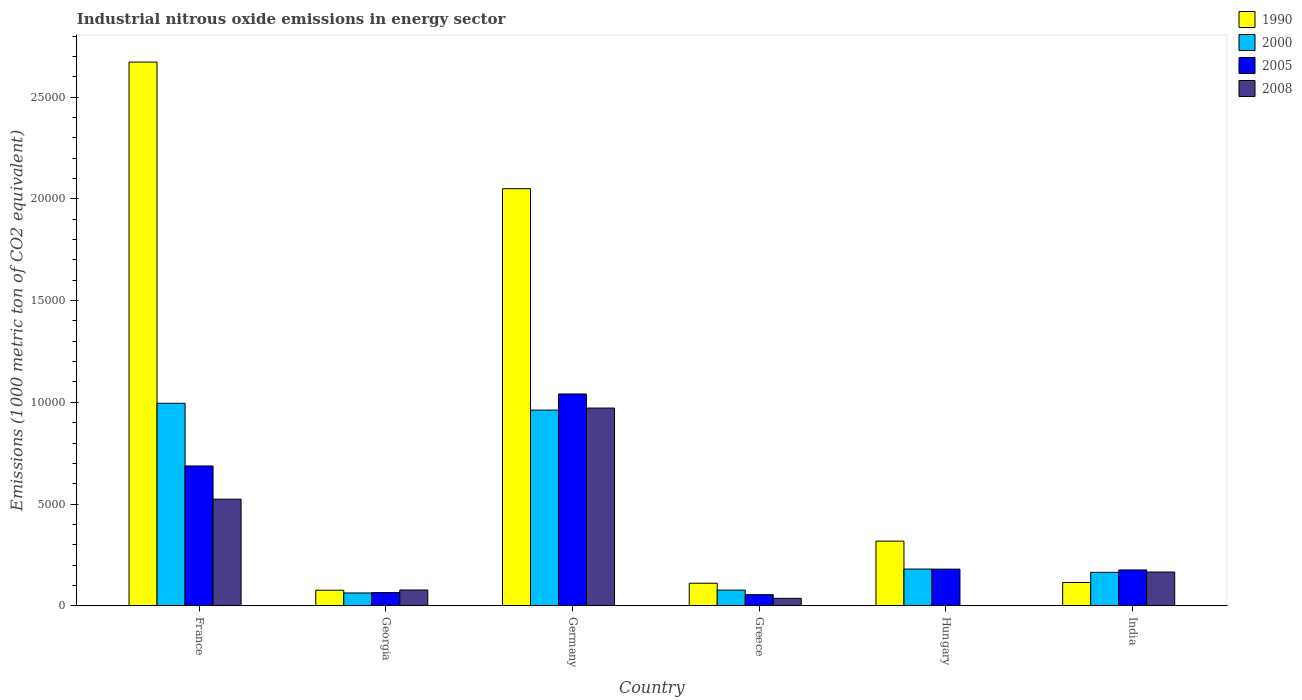How many different coloured bars are there?
Your answer should be compact. 4. How many groups of bars are there?
Provide a short and direct response. 6. Are the number of bars per tick equal to the number of legend labels?
Your answer should be compact. Yes. Are the number of bars on each tick of the X-axis equal?
Provide a succinct answer. Yes. How many bars are there on the 6th tick from the left?
Make the answer very short. 4. In how many cases, is the number of bars for a given country not equal to the number of legend labels?
Give a very brief answer. 0. What is the amount of industrial nitrous oxide emitted in 1990 in Germany?
Your answer should be compact. 2.05e+04. Across all countries, what is the maximum amount of industrial nitrous oxide emitted in 2008?
Your response must be concise. 9718.4. Across all countries, what is the minimum amount of industrial nitrous oxide emitted in 2005?
Offer a terse response. 545.8. In which country was the amount of industrial nitrous oxide emitted in 1990 maximum?
Make the answer very short. France. In which country was the amount of industrial nitrous oxide emitted in 2008 minimum?
Your answer should be compact. Hungary. What is the total amount of industrial nitrous oxide emitted in 2005 in the graph?
Keep it short and to the point. 2.20e+04. What is the difference between the amount of industrial nitrous oxide emitted in 2005 in France and that in Hungary?
Your answer should be compact. 5069.6. What is the difference between the amount of industrial nitrous oxide emitted in 2000 in France and the amount of industrial nitrous oxide emitted in 2005 in Hungary?
Give a very brief answer. 8151.8. What is the average amount of industrial nitrous oxide emitted in 2008 per country?
Your response must be concise. 2961.57. What is the difference between the amount of industrial nitrous oxide emitted of/in 2008 and amount of industrial nitrous oxide emitted of/in 2005 in France?
Offer a terse response. -1630.3. What is the ratio of the amount of industrial nitrous oxide emitted in 2005 in Germany to that in Greece?
Keep it short and to the point. 19.07. Is the amount of industrial nitrous oxide emitted in 2008 in Georgia less than that in India?
Ensure brevity in your answer.  Yes. What is the difference between the highest and the second highest amount of industrial nitrous oxide emitted in 1990?
Offer a very short reply. 6222.7. What is the difference between the highest and the lowest amount of industrial nitrous oxide emitted in 2005?
Your answer should be compact. 9863.1. Is the sum of the amount of industrial nitrous oxide emitted in 2008 in Georgia and Greece greater than the maximum amount of industrial nitrous oxide emitted in 2000 across all countries?
Offer a terse response. No. Is it the case that in every country, the sum of the amount of industrial nitrous oxide emitted in 2008 and amount of industrial nitrous oxide emitted in 1990 is greater than the sum of amount of industrial nitrous oxide emitted in 2000 and amount of industrial nitrous oxide emitted in 2005?
Provide a succinct answer. No. What does the 3rd bar from the right in Greece represents?
Your response must be concise. 2000. Is it the case that in every country, the sum of the amount of industrial nitrous oxide emitted in 1990 and amount of industrial nitrous oxide emitted in 2000 is greater than the amount of industrial nitrous oxide emitted in 2008?
Your answer should be very brief. Yes. How many bars are there?
Ensure brevity in your answer.  24. What is the difference between two consecutive major ticks on the Y-axis?
Keep it short and to the point. 5000. Does the graph contain any zero values?
Your answer should be compact. No. Does the graph contain grids?
Your answer should be very brief. No. Where does the legend appear in the graph?
Ensure brevity in your answer.  Top right. How many legend labels are there?
Make the answer very short. 4. How are the legend labels stacked?
Your answer should be very brief. Vertical. What is the title of the graph?
Provide a succinct answer. Industrial nitrous oxide emissions in energy sector. What is the label or title of the X-axis?
Make the answer very short. Country. What is the label or title of the Y-axis?
Provide a short and direct response. Emissions (1000 metric ton of CO2 equivalent). What is the Emissions (1000 metric ton of CO2 equivalent) in 1990 in France?
Your answer should be compact. 2.67e+04. What is the Emissions (1000 metric ton of CO2 equivalent) in 2000 in France?
Your answer should be compact. 9953.8. What is the Emissions (1000 metric ton of CO2 equivalent) of 2005 in France?
Make the answer very short. 6871.6. What is the Emissions (1000 metric ton of CO2 equivalent) in 2008 in France?
Make the answer very short. 5241.3. What is the Emissions (1000 metric ton of CO2 equivalent) in 1990 in Georgia?
Provide a short and direct response. 765.3. What is the Emissions (1000 metric ton of CO2 equivalent) of 2000 in Georgia?
Your answer should be very brief. 630.5. What is the Emissions (1000 metric ton of CO2 equivalent) in 2005 in Georgia?
Give a very brief answer. 650.1. What is the Emissions (1000 metric ton of CO2 equivalent) in 2008 in Georgia?
Ensure brevity in your answer.  776.5. What is the Emissions (1000 metric ton of CO2 equivalent) of 1990 in Germany?
Make the answer very short. 2.05e+04. What is the Emissions (1000 metric ton of CO2 equivalent) of 2000 in Germany?
Make the answer very short. 9617.9. What is the Emissions (1000 metric ton of CO2 equivalent) of 2005 in Germany?
Provide a short and direct response. 1.04e+04. What is the Emissions (1000 metric ton of CO2 equivalent) in 2008 in Germany?
Offer a very short reply. 9718.4. What is the Emissions (1000 metric ton of CO2 equivalent) in 1990 in Greece?
Give a very brief answer. 1109.1. What is the Emissions (1000 metric ton of CO2 equivalent) in 2000 in Greece?
Your answer should be compact. 771. What is the Emissions (1000 metric ton of CO2 equivalent) of 2005 in Greece?
Offer a terse response. 545.8. What is the Emissions (1000 metric ton of CO2 equivalent) in 2008 in Greece?
Provide a short and direct response. 367.4. What is the Emissions (1000 metric ton of CO2 equivalent) of 1990 in Hungary?
Give a very brief answer. 3178.6. What is the Emissions (1000 metric ton of CO2 equivalent) in 2000 in Hungary?
Ensure brevity in your answer.  1805.4. What is the Emissions (1000 metric ton of CO2 equivalent) in 2005 in Hungary?
Your answer should be very brief. 1802. What is the Emissions (1000 metric ton of CO2 equivalent) in 2008 in Hungary?
Your answer should be compact. 6. What is the Emissions (1000 metric ton of CO2 equivalent) of 1990 in India?
Offer a terse response. 1146.7. What is the Emissions (1000 metric ton of CO2 equivalent) in 2000 in India?
Make the answer very short. 1643.3. What is the Emissions (1000 metric ton of CO2 equivalent) of 2005 in India?
Give a very brief answer. 1761.9. What is the Emissions (1000 metric ton of CO2 equivalent) in 2008 in India?
Provide a short and direct response. 1659.8. Across all countries, what is the maximum Emissions (1000 metric ton of CO2 equivalent) of 1990?
Your response must be concise. 2.67e+04. Across all countries, what is the maximum Emissions (1000 metric ton of CO2 equivalent) of 2000?
Offer a very short reply. 9953.8. Across all countries, what is the maximum Emissions (1000 metric ton of CO2 equivalent) in 2005?
Ensure brevity in your answer.  1.04e+04. Across all countries, what is the maximum Emissions (1000 metric ton of CO2 equivalent) of 2008?
Ensure brevity in your answer.  9718.4. Across all countries, what is the minimum Emissions (1000 metric ton of CO2 equivalent) of 1990?
Provide a short and direct response. 765.3. Across all countries, what is the minimum Emissions (1000 metric ton of CO2 equivalent) of 2000?
Offer a very short reply. 630.5. Across all countries, what is the minimum Emissions (1000 metric ton of CO2 equivalent) of 2005?
Offer a terse response. 545.8. Across all countries, what is the minimum Emissions (1000 metric ton of CO2 equivalent) of 2008?
Offer a terse response. 6. What is the total Emissions (1000 metric ton of CO2 equivalent) of 1990 in the graph?
Offer a very short reply. 5.34e+04. What is the total Emissions (1000 metric ton of CO2 equivalent) in 2000 in the graph?
Ensure brevity in your answer.  2.44e+04. What is the total Emissions (1000 metric ton of CO2 equivalent) of 2005 in the graph?
Keep it short and to the point. 2.20e+04. What is the total Emissions (1000 metric ton of CO2 equivalent) of 2008 in the graph?
Provide a short and direct response. 1.78e+04. What is the difference between the Emissions (1000 metric ton of CO2 equivalent) in 1990 in France and that in Georgia?
Make the answer very short. 2.60e+04. What is the difference between the Emissions (1000 metric ton of CO2 equivalent) of 2000 in France and that in Georgia?
Your answer should be very brief. 9323.3. What is the difference between the Emissions (1000 metric ton of CO2 equivalent) of 2005 in France and that in Georgia?
Your response must be concise. 6221.5. What is the difference between the Emissions (1000 metric ton of CO2 equivalent) in 2008 in France and that in Georgia?
Make the answer very short. 4464.8. What is the difference between the Emissions (1000 metric ton of CO2 equivalent) of 1990 in France and that in Germany?
Your answer should be very brief. 6222.7. What is the difference between the Emissions (1000 metric ton of CO2 equivalent) of 2000 in France and that in Germany?
Provide a short and direct response. 335.9. What is the difference between the Emissions (1000 metric ton of CO2 equivalent) in 2005 in France and that in Germany?
Give a very brief answer. -3537.3. What is the difference between the Emissions (1000 metric ton of CO2 equivalent) of 2008 in France and that in Germany?
Provide a succinct answer. -4477.1. What is the difference between the Emissions (1000 metric ton of CO2 equivalent) in 1990 in France and that in Greece?
Give a very brief answer. 2.56e+04. What is the difference between the Emissions (1000 metric ton of CO2 equivalent) in 2000 in France and that in Greece?
Offer a terse response. 9182.8. What is the difference between the Emissions (1000 metric ton of CO2 equivalent) of 2005 in France and that in Greece?
Ensure brevity in your answer.  6325.8. What is the difference between the Emissions (1000 metric ton of CO2 equivalent) of 2008 in France and that in Greece?
Provide a short and direct response. 4873.9. What is the difference between the Emissions (1000 metric ton of CO2 equivalent) in 1990 in France and that in Hungary?
Your response must be concise. 2.35e+04. What is the difference between the Emissions (1000 metric ton of CO2 equivalent) of 2000 in France and that in Hungary?
Your answer should be compact. 8148.4. What is the difference between the Emissions (1000 metric ton of CO2 equivalent) of 2005 in France and that in Hungary?
Keep it short and to the point. 5069.6. What is the difference between the Emissions (1000 metric ton of CO2 equivalent) of 2008 in France and that in Hungary?
Offer a terse response. 5235.3. What is the difference between the Emissions (1000 metric ton of CO2 equivalent) in 1990 in France and that in India?
Offer a terse response. 2.56e+04. What is the difference between the Emissions (1000 metric ton of CO2 equivalent) of 2000 in France and that in India?
Provide a short and direct response. 8310.5. What is the difference between the Emissions (1000 metric ton of CO2 equivalent) of 2005 in France and that in India?
Your answer should be compact. 5109.7. What is the difference between the Emissions (1000 metric ton of CO2 equivalent) in 2008 in France and that in India?
Your answer should be compact. 3581.5. What is the difference between the Emissions (1000 metric ton of CO2 equivalent) of 1990 in Georgia and that in Germany?
Ensure brevity in your answer.  -1.97e+04. What is the difference between the Emissions (1000 metric ton of CO2 equivalent) in 2000 in Georgia and that in Germany?
Your answer should be very brief. -8987.4. What is the difference between the Emissions (1000 metric ton of CO2 equivalent) in 2005 in Georgia and that in Germany?
Your answer should be very brief. -9758.8. What is the difference between the Emissions (1000 metric ton of CO2 equivalent) in 2008 in Georgia and that in Germany?
Keep it short and to the point. -8941.9. What is the difference between the Emissions (1000 metric ton of CO2 equivalent) in 1990 in Georgia and that in Greece?
Your answer should be very brief. -343.8. What is the difference between the Emissions (1000 metric ton of CO2 equivalent) in 2000 in Georgia and that in Greece?
Give a very brief answer. -140.5. What is the difference between the Emissions (1000 metric ton of CO2 equivalent) of 2005 in Georgia and that in Greece?
Your answer should be compact. 104.3. What is the difference between the Emissions (1000 metric ton of CO2 equivalent) in 2008 in Georgia and that in Greece?
Provide a short and direct response. 409.1. What is the difference between the Emissions (1000 metric ton of CO2 equivalent) in 1990 in Georgia and that in Hungary?
Make the answer very short. -2413.3. What is the difference between the Emissions (1000 metric ton of CO2 equivalent) in 2000 in Georgia and that in Hungary?
Provide a short and direct response. -1174.9. What is the difference between the Emissions (1000 metric ton of CO2 equivalent) in 2005 in Georgia and that in Hungary?
Ensure brevity in your answer.  -1151.9. What is the difference between the Emissions (1000 metric ton of CO2 equivalent) of 2008 in Georgia and that in Hungary?
Give a very brief answer. 770.5. What is the difference between the Emissions (1000 metric ton of CO2 equivalent) of 1990 in Georgia and that in India?
Offer a terse response. -381.4. What is the difference between the Emissions (1000 metric ton of CO2 equivalent) of 2000 in Georgia and that in India?
Offer a very short reply. -1012.8. What is the difference between the Emissions (1000 metric ton of CO2 equivalent) of 2005 in Georgia and that in India?
Your response must be concise. -1111.8. What is the difference between the Emissions (1000 metric ton of CO2 equivalent) of 2008 in Georgia and that in India?
Keep it short and to the point. -883.3. What is the difference between the Emissions (1000 metric ton of CO2 equivalent) of 1990 in Germany and that in Greece?
Ensure brevity in your answer.  1.94e+04. What is the difference between the Emissions (1000 metric ton of CO2 equivalent) of 2000 in Germany and that in Greece?
Make the answer very short. 8846.9. What is the difference between the Emissions (1000 metric ton of CO2 equivalent) in 2005 in Germany and that in Greece?
Your answer should be compact. 9863.1. What is the difference between the Emissions (1000 metric ton of CO2 equivalent) of 2008 in Germany and that in Greece?
Give a very brief answer. 9351. What is the difference between the Emissions (1000 metric ton of CO2 equivalent) in 1990 in Germany and that in Hungary?
Your answer should be compact. 1.73e+04. What is the difference between the Emissions (1000 metric ton of CO2 equivalent) of 2000 in Germany and that in Hungary?
Your answer should be compact. 7812.5. What is the difference between the Emissions (1000 metric ton of CO2 equivalent) of 2005 in Germany and that in Hungary?
Your response must be concise. 8606.9. What is the difference between the Emissions (1000 metric ton of CO2 equivalent) of 2008 in Germany and that in Hungary?
Your response must be concise. 9712.4. What is the difference between the Emissions (1000 metric ton of CO2 equivalent) in 1990 in Germany and that in India?
Give a very brief answer. 1.94e+04. What is the difference between the Emissions (1000 metric ton of CO2 equivalent) in 2000 in Germany and that in India?
Make the answer very short. 7974.6. What is the difference between the Emissions (1000 metric ton of CO2 equivalent) of 2005 in Germany and that in India?
Provide a succinct answer. 8647. What is the difference between the Emissions (1000 metric ton of CO2 equivalent) in 2008 in Germany and that in India?
Your answer should be very brief. 8058.6. What is the difference between the Emissions (1000 metric ton of CO2 equivalent) in 1990 in Greece and that in Hungary?
Your answer should be compact. -2069.5. What is the difference between the Emissions (1000 metric ton of CO2 equivalent) of 2000 in Greece and that in Hungary?
Ensure brevity in your answer.  -1034.4. What is the difference between the Emissions (1000 metric ton of CO2 equivalent) in 2005 in Greece and that in Hungary?
Your answer should be compact. -1256.2. What is the difference between the Emissions (1000 metric ton of CO2 equivalent) in 2008 in Greece and that in Hungary?
Keep it short and to the point. 361.4. What is the difference between the Emissions (1000 metric ton of CO2 equivalent) in 1990 in Greece and that in India?
Your answer should be compact. -37.6. What is the difference between the Emissions (1000 metric ton of CO2 equivalent) in 2000 in Greece and that in India?
Ensure brevity in your answer.  -872.3. What is the difference between the Emissions (1000 metric ton of CO2 equivalent) of 2005 in Greece and that in India?
Provide a succinct answer. -1216.1. What is the difference between the Emissions (1000 metric ton of CO2 equivalent) of 2008 in Greece and that in India?
Keep it short and to the point. -1292.4. What is the difference between the Emissions (1000 metric ton of CO2 equivalent) of 1990 in Hungary and that in India?
Provide a short and direct response. 2031.9. What is the difference between the Emissions (1000 metric ton of CO2 equivalent) in 2000 in Hungary and that in India?
Offer a terse response. 162.1. What is the difference between the Emissions (1000 metric ton of CO2 equivalent) of 2005 in Hungary and that in India?
Give a very brief answer. 40.1. What is the difference between the Emissions (1000 metric ton of CO2 equivalent) in 2008 in Hungary and that in India?
Provide a short and direct response. -1653.8. What is the difference between the Emissions (1000 metric ton of CO2 equivalent) of 1990 in France and the Emissions (1000 metric ton of CO2 equivalent) of 2000 in Georgia?
Give a very brief answer. 2.61e+04. What is the difference between the Emissions (1000 metric ton of CO2 equivalent) in 1990 in France and the Emissions (1000 metric ton of CO2 equivalent) in 2005 in Georgia?
Offer a very short reply. 2.61e+04. What is the difference between the Emissions (1000 metric ton of CO2 equivalent) of 1990 in France and the Emissions (1000 metric ton of CO2 equivalent) of 2008 in Georgia?
Keep it short and to the point. 2.59e+04. What is the difference between the Emissions (1000 metric ton of CO2 equivalent) in 2000 in France and the Emissions (1000 metric ton of CO2 equivalent) in 2005 in Georgia?
Your answer should be very brief. 9303.7. What is the difference between the Emissions (1000 metric ton of CO2 equivalent) of 2000 in France and the Emissions (1000 metric ton of CO2 equivalent) of 2008 in Georgia?
Provide a succinct answer. 9177.3. What is the difference between the Emissions (1000 metric ton of CO2 equivalent) of 2005 in France and the Emissions (1000 metric ton of CO2 equivalent) of 2008 in Georgia?
Keep it short and to the point. 6095.1. What is the difference between the Emissions (1000 metric ton of CO2 equivalent) in 1990 in France and the Emissions (1000 metric ton of CO2 equivalent) in 2000 in Germany?
Provide a short and direct response. 1.71e+04. What is the difference between the Emissions (1000 metric ton of CO2 equivalent) of 1990 in France and the Emissions (1000 metric ton of CO2 equivalent) of 2005 in Germany?
Offer a very short reply. 1.63e+04. What is the difference between the Emissions (1000 metric ton of CO2 equivalent) of 1990 in France and the Emissions (1000 metric ton of CO2 equivalent) of 2008 in Germany?
Your answer should be very brief. 1.70e+04. What is the difference between the Emissions (1000 metric ton of CO2 equivalent) in 2000 in France and the Emissions (1000 metric ton of CO2 equivalent) in 2005 in Germany?
Make the answer very short. -455.1. What is the difference between the Emissions (1000 metric ton of CO2 equivalent) of 2000 in France and the Emissions (1000 metric ton of CO2 equivalent) of 2008 in Germany?
Offer a very short reply. 235.4. What is the difference between the Emissions (1000 metric ton of CO2 equivalent) of 2005 in France and the Emissions (1000 metric ton of CO2 equivalent) of 2008 in Germany?
Ensure brevity in your answer.  -2846.8. What is the difference between the Emissions (1000 metric ton of CO2 equivalent) in 1990 in France and the Emissions (1000 metric ton of CO2 equivalent) in 2000 in Greece?
Ensure brevity in your answer.  2.60e+04. What is the difference between the Emissions (1000 metric ton of CO2 equivalent) in 1990 in France and the Emissions (1000 metric ton of CO2 equivalent) in 2005 in Greece?
Ensure brevity in your answer.  2.62e+04. What is the difference between the Emissions (1000 metric ton of CO2 equivalent) in 1990 in France and the Emissions (1000 metric ton of CO2 equivalent) in 2008 in Greece?
Keep it short and to the point. 2.64e+04. What is the difference between the Emissions (1000 metric ton of CO2 equivalent) in 2000 in France and the Emissions (1000 metric ton of CO2 equivalent) in 2005 in Greece?
Your answer should be very brief. 9408. What is the difference between the Emissions (1000 metric ton of CO2 equivalent) of 2000 in France and the Emissions (1000 metric ton of CO2 equivalent) of 2008 in Greece?
Offer a terse response. 9586.4. What is the difference between the Emissions (1000 metric ton of CO2 equivalent) in 2005 in France and the Emissions (1000 metric ton of CO2 equivalent) in 2008 in Greece?
Make the answer very short. 6504.2. What is the difference between the Emissions (1000 metric ton of CO2 equivalent) in 1990 in France and the Emissions (1000 metric ton of CO2 equivalent) in 2000 in Hungary?
Ensure brevity in your answer.  2.49e+04. What is the difference between the Emissions (1000 metric ton of CO2 equivalent) in 1990 in France and the Emissions (1000 metric ton of CO2 equivalent) in 2005 in Hungary?
Ensure brevity in your answer.  2.49e+04. What is the difference between the Emissions (1000 metric ton of CO2 equivalent) of 1990 in France and the Emissions (1000 metric ton of CO2 equivalent) of 2008 in Hungary?
Keep it short and to the point. 2.67e+04. What is the difference between the Emissions (1000 metric ton of CO2 equivalent) in 2000 in France and the Emissions (1000 metric ton of CO2 equivalent) in 2005 in Hungary?
Provide a succinct answer. 8151.8. What is the difference between the Emissions (1000 metric ton of CO2 equivalent) of 2000 in France and the Emissions (1000 metric ton of CO2 equivalent) of 2008 in Hungary?
Provide a short and direct response. 9947.8. What is the difference between the Emissions (1000 metric ton of CO2 equivalent) of 2005 in France and the Emissions (1000 metric ton of CO2 equivalent) of 2008 in Hungary?
Make the answer very short. 6865.6. What is the difference between the Emissions (1000 metric ton of CO2 equivalent) of 1990 in France and the Emissions (1000 metric ton of CO2 equivalent) of 2000 in India?
Your response must be concise. 2.51e+04. What is the difference between the Emissions (1000 metric ton of CO2 equivalent) in 1990 in France and the Emissions (1000 metric ton of CO2 equivalent) in 2005 in India?
Provide a succinct answer. 2.50e+04. What is the difference between the Emissions (1000 metric ton of CO2 equivalent) of 1990 in France and the Emissions (1000 metric ton of CO2 equivalent) of 2008 in India?
Make the answer very short. 2.51e+04. What is the difference between the Emissions (1000 metric ton of CO2 equivalent) in 2000 in France and the Emissions (1000 metric ton of CO2 equivalent) in 2005 in India?
Ensure brevity in your answer.  8191.9. What is the difference between the Emissions (1000 metric ton of CO2 equivalent) of 2000 in France and the Emissions (1000 metric ton of CO2 equivalent) of 2008 in India?
Provide a succinct answer. 8294. What is the difference between the Emissions (1000 metric ton of CO2 equivalent) of 2005 in France and the Emissions (1000 metric ton of CO2 equivalent) of 2008 in India?
Keep it short and to the point. 5211.8. What is the difference between the Emissions (1000 metric ton of CO2 equivalent) of 1990 in Georgia and the Emissions (1000 metric ton of CO2 equivalent) of 2000 in Germany?
Keep it short and to the point. -8852.6. What is the difference between the Emissions (1000 metric ton of CO2 equivalent) of 1990 in Georgia and the Emissions (1000 metric ton of CO2 equivalent) of 2005 in Germany?
Ensure brevity in your answer.  -9643.6. What is the difference between the Emissions (1000 metric ton of CO2 equivalent) of 1990 in Georgia and the Emissions (1000 metric ton of CO2 equivalent) of 2008 in Germany?
Your answer should be compact. -8953.1. What is the difference between the Emissions (1000 metric ton of CO2 equivalent) in 2000 in Georgia and the Emissions (1000 metric ton of CO2 equivalent) in 2005 in Germany?
Give a very brief answer. -9778.4. What is the difference between the Emissions (1000 metric ton of CO2 equivalent) in 2000 in Georgia and the Emissions (1000 metric ton of CO2 equivalent) in 2008 in Germany?
Keep it short and to the point. -9087.9. What is the difference between the Emissions (1000 metric ton of CO2 equivalent) of 2005 in Georgia and the Emissions (1000 metric ton of CO2 equivalent) of 2008 in Germany?
Offer a terse response. -9068.3. What is the difference between the Emissions (1000 metric ton of CO2 equivalent) of 1990 in Georgia and the Emissions (1000 metric ton of CO2 equivalent) of 2000 in Greece?
Your answer should be compact. -5.7. What is the difference between the Emissions (1000 metric ton of CO2 equivalent) of 1990 in Georgia and the Emissions (1000 metric ton of CO2 equivalent) of 2005 in Greece?
Keep it short and to the point. 219.5. What is the difference between the Emissions (1000 metric ton of CO2 equivalent) of 1990 in Georgia and the Emissions (1000 metric ton of CO2 equivalent) of 2008 in Greece?
Provide a short and direct response. 397.9. What is the difference between the Emissions (1000 metric ton of CO2 equivalent) in 2000 in Georgia and the Emissions (1000 metric ton of CO2 equivalent) in 2005 in Greece?
Keep it short and to the point. 84.7. What is the difference between the Emissions (1000 metric ton of CO2 equivalent) in 2000 in Georgia and the Emissions (1000 metric ton of CO2 equivalent) in 2008 in Greece?
Give a very brief answer. 263.1. What is the difference between the Emissions (1000 metric ton of CO2 equivalent) of 2005 in Georgia and the Emissions (1000 metric ton of CO2 equivalent) of 2008 in Greece?
Keep it short and to the point. 282.7. What is the difference between the Emissions (1000 metric ton of CO2 equivalent) of 1990 in Georgia and the Emissions (1000 metric ton of CO2 equivalent) of 2000 in Hungary?
Give a very brief answer. -1040.1. What is the difference between the Emissions (1000 metric ton of CO2 equivalent) of 1990 in Georgia and the Emissions (1000 metric ton of CO2 equivalent) of 2005 in Hungary?
Give a very brief answer. -1036.7. What is the difference between the Emissions (1000 metric ton of CO2 equivalent) in 1990 in Georgia and the Emissions (1000 metric ton of CO2 equivalent) in 2008 in Hungary?
Provide a short and direct response. 759.3. What is the difference between the Emissions (1000 metric ton of CO2 equivalent) of 2000 in Georgia and the Emissions (1000 metric ton of CO2 equivalent) of 2005 in Hungary?
Keep it short and to the point. -1171.5. What is the difference between the Emissions (1000 metric ton of CO2 equivalent) in 2000 in Georgia and the Emissions (1000 metric ton of CO2 equivalent) in 2008 in Hungary?
Your answer should be compact. 624.5. What is the difference between the Emissions (1000 metric ton of CO2 equivalent) in 2005 in Georgia and the Emissions (1000 metric ton of CO2 equivalent) in 2008 in Hungary?
Your answer should be very brief. 644.1. What is the difference between the Emissions (1000 metric ton of CO2 equivalent) in 1990 in Georgia and the Emissions (1000 metric ton of CO2 equivalent) in 2000 in India?
Your answer should be very brief. -878. What is the difference between the Emissions (1000 metric ton of CO2 equivalent) of 1990 in Georgia and the Emissions (1000 metric ton of CO2 equivalent) of 2005 in India?
Your answer should be very brief. -996.6. What is the difference between the Emissions (1000 metric ton of CO2 equivalent) in 1990 in Georgia and the Emissions (1000 metric ton of CO2 equivalent) in 2008 in India?
Your response must be concise. -894.5. What is the difference between the Emissions (1000 metric ton of CO2 equivalent) in 2000 in Georgia and the Emissions (1000 metric ton of CO2 equivalent) in 2005 in India?
Offer a very short reply. -1131.4. What is the difference between the Emissions (1000 metric ton of CO2 equivalent) of 2000 in Georgia and the Emissions (1000 metric ton of CO2 equivalent) of 2008 in India?
Your response must be concise. -1029.3. What is the difference between the Emissions (1000 metric ton of CO2 equivalent) of 2005 in Georgia and the Emissions (1000 metric ton of CO2 equivalent) of 2008 in India?
Your answer should be compact. -1009.7. What is the difference between the Emissions (1000 metric ton of CO2 equivalent) of 1990 in Germany and the Emissions (1000 metric ton of CO2 equivalent) of 2000 in Greece?
Your answer should be very brief. 1.97e+04. What is the difference between the Emissions (1000 metric ton of CO2 equivalent) of 1990 in Germany and the Emissions (1000 metric ton of CO2 equivalent) of 2005 in Greece?
Your answer should be compact. 2.00e+04. What is the difference between the Emissions (1000 metric ton of CO2 equivalent) in 1990 in Germany and the Emissions (1000 metric ton of CO2 equivalent) in 2008 in Greece?
Make the answer very short. 2.01e+04. What is the difference between the Emissions (1000 metric ton of CO2 equivalent) of 2000 in Germany and the Emissions (1000 metric ton of CO2 equivalent) of 2005 in Greece?
Make the answer very short. 9072.1. What is the difference between the Emissions (1000 metric ton of CO2 equivalent) of 2000 in Germany and the Emissions (1000 metric ton of CO2 equivalent) of 2008 in Greece?
Offer a terse response. 9250.5. What is the difference between the Emissions (1000 metric ton of CO2 equivalent) in 2005 in Germany and the Emissions (1000 metric ton of CO2 equivalent) in 2008 in Greece?
Your answer should be compact. 1.00e+04. What is the difference between the Emissions (1000 metric ton of CO2 equivalent) of 1990 in Germany and the Emissions (1000 metric ton of CO2 equivalent) of 2000 in Hungary?
Make the answer very short. 1.87e+04. What is the difference between the Emissions (1000 metric ton of CO2 equivalent) of 1990 in Germany and the Emissions (1000 metric ton of CO2 equivalent) of 2005 in Hungary?
Offer a terse response. 1.87e+04. What is the difference between the Emissions (1000 metric ton of CO2 equivalent) in 1990 in Germany and the Emissions (1000 metric ton of CO2 equivalent) in 2008 in Hungary?
Keep it short and to the point. 2.05e+04. What is the difference between the Emissions (1000 metric ton of CO2 equivalent) in 2000 in Germany and the Emissions (1000 metric ton of CO2 equivalent) in 2005 in Hungary?
Ensure brevity in your answer.  7815.9. What is the difference between the Emissions (1000 metric ton of CO2 equivalent) of 2000 in Germany and the Emissions (1000 metric ton of CO2 equivalent) of 2008 in Hungary?
Provide a succinct answer. 9611.9. What is the difference between the Emissions (1000 metric ton of CO2 equivalent) of 2005 in Germany and the Emissions (1000 metric ton of CO2 equivalent) of 2008 in Hungary?
Your answer should be very brief. 1.04e+04. What is the difference between the Emissions (1000 metric ton of CO2 equivalent) of 1990 in Germany and the Emissions (1000 metric ton of CO2 equivalent) of 2000 in India?
Your answer should be compact. 1.89e+04. What is the difference between the Emissions (1000 metric ton of CO2 equivalent) in 1990 in Germany and the Emissions (1000 metric ton of CO2 equivalent) in 2005 in India?
Provide a succinct answer. 1.87e+04. What is the difference between the Emissions (1000 metric ton of CO2 equivalent) in 1990 in Germany and the Emissions (1000 metric ton of CO2 equivalent) in 2008 in India?
Provide a succinct answer. 1.88e+04. What is the difference between the Emissions (1000 metric ton of CO2 equivalent) in 2000 in Germany and the Emissions (1000 metric ton of CO2 equivalent) in 2005 in India?
Keep it short and to the point. 7856. What is the difference between the Emissions (1000 metric ton of CO2 equivalent) in 2000 in Germany and the Emissions (1000 metric ton of CO2 equivalent) in 2008 in India?
Offer a terse response. 7958.1. What is the difference between the Emissions (1000 metric ton of CO2 equivalent) in 2005 in Germany and the Emissions (1000 metric ton of CO2 equivalent) in 2008 in India?
Your answer should be very brief. 8749.1. What is the difference between the Emissions (1000 metric ton of CO2 equivalent) in 1990 in Greece and the Emissions (1000 metric ton of CO2 equivalent) in 2000 in Hungary?
Your response must be concise. -696.3. What is the difference between the Emissions (1000 metric ton of CO2 equivalent) in 1990 in Greece and the Emissions (1000 metric ton of CO2 equivalent) in 2005 in Hungary?
Offer a very short reply. -692.9. What is the difference between the Emissions (1000 metric ton of CO2 equivalent) in 1990 in Greece and the Emissions (1000 metric ton of CO2 equivalent) in 2008 in Hungary?
Your answer should be compact. 1103.1. What is the difference between the Emissions (1000 metric ton of CO2 equivalent) of 2000 in Greece and the Emissions (1000 metric ton of CO2 equivalent) of 2005 in Hungary?
Ensure brevity in your answer.  -1031. What is the difference between the Emissions (1000 metric ton of CO2 equivalent) of 2000 in Greece and the Emissions (1000 metric ton of CO2 equivalent) of 2008 in Hungary?
Give a very brief answer. 765. What is the difference between the Emissions (1000 metric ton of CO2 equivalent) in 2005 in Greece and the Emissions (1000 metric ton of CO2 equivalent) in 2008 in Hungary?
Give a very brief answer. 539.8. What is the difference between the Emissions (1000 metric ton of CO2 equivalent) of 1990 in Greece and the Emissions (1000 metric ton of CO2 equivalent) of 2000 in India?
Provide a short and direct response. -534.2. What is the difference between the Emissions (1000 metric ton of CO2 equivalent) in 1990 in Greece and the Emissions (1000 metric ton of CO2 equivalent) in 2005 in India?
Make the answer very short. -652.8. What is the difference between the Emissions (1000 metric ton of CO2 equivalent) in 1990 in Greece and the Emissions (1000 metric ton of CO2 equivalent) in 2008 in India?
Provide a succinct answer. -550.7. What is the difference between the Emissions (1000 metric ton of CO2 equivalent) of 2000 in Greece and the Emissions (1000 metric ton of CO2 equivalent) of 2005 in India?
Give a very brief answer. -990.9. What is the difference between the Emissions (1000 metric ton of CO2 equivalent) in 2000 in Greece and the Emissions (1000 metric ton of CO2 equivalent) in 2008 in India?
Provide a short and direct response. -888.8. What is the difference between the Emissions (1000 metric ton of CO2 equivalent) in 2005 in Greece and the Emissions (1000 metric ton of CO2 equivalent) in 2008 in India?
Offer a terse response. -1114. What is the difference between the Emissions (1000 metric ton of CO2 equivalent) in 1990 in Hungary and the Emissions (1000 metric ton of CO2 equivalent) in 2000 in India?
Your response must be concise. 1535.3. What is the difference between the Emissions (1000 metric ton of CO2 equivalent) in 1990 in Hungary and the Emissions (1000 metric ton of CO2 equivalent) in 2005 in India?
Your answer should be compact. 1416.7. What is the difference between the Emissions (1000 metric ton of CO2 equivalent) in 1990 in Hungary and the Emissions (1000 metric ton of CO2 equivalent) in 2008 in India?
Give a very brief answer. 1518.8. What is the difference between the Emissions (1000 metric ton of CO2 equivalent) of 2000 in Hungary and the Emissions (1000 metric ton of CO2 equivalent) of 2005 in India?
Provide a succinct answer. 43.5. What is the difference between the Emissions (1000 metric ton of CO2 equivalent) of 2000 in Hungary and the Emissions (1000 metric ton of CO2 equivalent) of 2008 in India?
Offer a terse response. 145.6. What is the difference between the Emissions (1000 metric ton of CO2 equivalent) of 2005 in Hungary and the Emissions (1000 metric ton of CO2 equivalent) of 2008 in India?
Provide a succinct answer. 142.2. What is the average Emissions (1000 metric ton of CO2 equivalent) in 1990 per country?
Offer a terse response. 8903.6. What is the average Emissions (1000 metric ton of CO2 equivalent) of 2000 per country?
Your answer should be very brief. 4070.32. What is the average Emissions (1000 metric ton of CO2 equivalent) of 2005 per country?
Offer a very short reply. 3673.38. What is the average Emissions (1000 metric ton of CO2 equivalent) of 2008 per country?
Offer a very short reply. 2961.57. What is the difference between the Emissions (1000 metric ton of CO2 equivalent) of 1990 and Emissions (1000 metric ton of CO2 equivalent) of 2000 in France?
Your answer should be compact. 1.68e+04. What is the difference between the Emissions (1000 metric ton of CO2 equivalent) of 1990 and Emissions (1000 metric ton of CO2 equivalent) of 2005 in France?
Make the answer very short. 1.99e+04. What is the difference between the Emissions (1000 metric ton of CO2 equivalent) of 1990 and Emissions (1000 metric ton of CO2 equivalent) of 2008 in France?
Keep it short and to the point. 2.15e+04. What is the difference between the Emissions (1000 metric ton of CO2 equivalent) in 2000 and Emissions (1000 metric ton of CO2 equivalent) in 2005 in France?
Provide a short and direct response. 3082.2. What is the difference between the Emissions (1000 metric ton of CO2 equivalent) in 2000 and Emissions (1000 metric ton of CO2 equivalent) in 2008 in France?
Offer a terse response. 4712.5. What is the difference between the Emissions (1000 metric ton of CO2 equivalent) of 2005 and Emissions (1000 metric ton of CO2 equivalent) of 2008 in France?
Keep it short and to the point. 1630.3. What is the difference between the Emissions (1000 metric ton of CO2 equivalent) in 1990 and Emissions (1000 metric ton of CO2 equivalent) in 2000 in Georgia?
Your response must be concise. 134.8. What is the difference between the Emissions (1000 metric ton of CO2 equivalent) in 1990 and Emissions (1000 metric ton of CO2 equivalent) in 2005 in Georgia?
Make the answer very short. 115.2. What is the difference between the Emissions (1000 metric ton of CO2 equivalent) in 2000 and Emissions (1000 metric ton of CO2 equivalent) in 2005 in Georgia?
Your answer should be very brief. -19.6. What is the difference between the Emissions (1000 metric ton of CO2 equivalent) in 2000 and Emissions (1000 metric ton of CO2 equivalent) in 2008 in Georgia?
Your answer should be very brief. -146. What is the difference between the Emissions (1000 metric ton of CO2 equivalent) of 2005 and Emissions (1000 metric ton of CO2 equivalent) of 2008 in Georgia?
Offer a very short reply. -126.4. What is the difference between the Emissions (1000 metric ton of CO2 equivalent) in 1990 and Emissions (1000 metric ton of CO2 equivalent) in 2000 in Germany?
Your answer should be very brief. 1.09e+04. What is the difference between the Emissions (1000 metric ton of CO2 equivalent) in 1990 and Emissions (1000 metric ton of CO2 equivalent) in 2005 in Germany?
Provide a succinct answer. 1.01e+04. What is the difference between the Emissions (1000 metric ton of CO2 equivalent) in 1990 and Emissions (1000 metric ton of CO2 equivalent) in 2008 in Germany?
Offer a terse response. 1.08e+04. What is the difference between the Emissions (1000 metric ton of CO2 equivalent) of 2000 and Emissions (1000 metric ton of CO2 equivalent) of 2005 in Germany?
Make the answer very short. -791. What is the difference between the Emissions (1000 metric ton of CO2 equivalent) of 2000 and Emissions (1000 metric ton of CO2 equivalent) of 2008 in Germany?
Ensure brevity in your answer.  -100.5. What is the difference between the Emissions (1000 metric ton of CO2 equivalent) of 2005 and Emissions (1000 metric ton of CO2 equivalent) of 2008 in Germany?
Ensure brevity in your answer.  690.5. What is the difference between the Emissions (1000 metric ton of CO2 equivalent) in 1990 and Emissions (1000 metric ton of CO2 equivalent) in 2000 in Greece?
Offer a terse response. 338.1. What is the difference between the Emissions (1000 metric ton of CO2 equivalent) of 1990 and Emissions (1000 metric ton of CO2 equivalent) of 2005 in Greece?
Offer a terse response. 563.3. What is the difference between the Emissions (1000 metric ton of CO2 equivalent) of 1990 and Emissions (1000 metric ton of CO2 equivalent) of 2008 in Greece?
Offer a terse response. 741.7. What is the difference between the Emissions (1000 metric ton of CO2 equivalent) in 2000 and Emissions (1000 metric ton of CO2 equivalent) in 2005 in Greece?
Keep it short and to the point. 225.2. What is the difference between the Emissions (1000 metric ton of CO2 equivalent) of 2000 and Emissions (1000 metric ton of CO2 equivalent) of 2008 in Greece?
Provide a succinct answer. 403.6. What is the difference between the Emissions (1000 metric ton of CO2 equivalent) of 2005 and Emissions (1000 metric ton of CO2 equivalent) of 2008 in Greece?
Provide a succinct answer. 178.4. What is the difference between the Emissions (1000 metric ton of CO2 equivalent) in 1990 and Emissions (1000 metric ton of CO2 equivalent) in 2000 in Hungary?
Offer a terse response. 1373.2. What is the difference between the Emissions (1000 metric ton of CO2 equivalent) of 1990 and Emissions (1000 metric ton of CO2 equivalent) of 2005 in Hungary?
Provide a succinct answer. 1376.6. What is the difference between the Emissions (1000 metric ton of CO2 equivalent) of 1990 and Emissions (1000 metric ton of CO2 equivalent) of 2008 in Hungary?
Make the answer very short. 3172.6. What is the difference between the Emissions (1000 metric ton of CO2 equivalent) in 2000 and Emissions (1000 metric ton of CO2 equivalent) in 2008 in Hungary?
Provide a succinct answer. 1799.4. What is the difference between the Emissions (1000 metric ton of CO2 equivalent) of 2005 and Emissions (1000 metric ton of CO2 equivalent) of 2008 in Hungary?
Offer a terse response. 1796. What is the difference between the Emissions (1000 metric ton of CO2 equivalent) in 1990 and Emissions (1000 metric ton of CO2 equivalent) in 2000 in India?
Give a very brief answer. -496.6. What is the difference between the Emissions (1000 metric ton of CO2 equivalent) in 1990 and Emissions (1000 metric ton of CO2 equivalent) in 2005 in India?
Your answer should be compact. -615.2. What is the difference between the Emissions (1000 metric ton of CO2 equivalent) in 1990 and Emissions (1000 metric ton of CO2 equivalent) in 2008 in India?
Your answer should be very brief. -513.1. What is the difference between the Emissions (1000 metric ton of CO2 equivalent) in 2000 and Emissions (1000 metric ton of CO2 equivalent) in 2005 in India?
Offer a very short reply. -118.6. What is the difference between the Emissions (1000 metric ton of CO2 equivalent) of 2000 and Emissions (1000 metric ton of CO2 equivalent) of 2008 in India?
Keep it short and to the point. -16.5. What is the difference between the Emissions (1000 metric ton of CO2 equivalent) in 2005 and Emissions (1000 metric ton of CO2 equivalent) in 2008 in India?
Provide a short and direct response. 102.1. What is the ratio of the Emissions (1000 metric ton of CO2 equivalent) of 1990 in France to that in Georgia?
Provide a short and direct response. 34.92. What is the ratio of the Emissions (1000 metric ton of CO2 equivalent) of 2000 in France to that in Georgia?
Offer a terse response. 15.79. What is the ratio of the Emissions (1000 metric ton of CO2 equivalent) in 2005 in France to that in Georgia?
Provide a short and direct response. 10.57. What is the ratio of the Emissions (1000 metric ton of CO2 equivalent) in 2008 in France to that in Georgia?
Provide a succinct answer. 6.75. What is the ratio of the Emissions (1000 metric ton of CO2 equivalent) in 1990 in France to that in Germany?
Provide a succinct answer. 1.3. What is the ratio of the Emissions (1000 metric ton of CO2 equivalent) of 2000 in France to that in Germany?
Ensure brevity in your answer.  1.03. What is the ratio of the Emissions (1000 metric ton of CO2 equivalent) of 2005 in France to that in Germany?
Your response must be concise. 0.66. What is the ratio of the Emissions (1000 metric ton of CO2 equivalent) of 2008 in France to that in Germany?
Provide a short and direct response. 0.54. What is the ratio of the Emissions (1000 metric ton of CO2 equivalent) of 1990 in France to that in Greece?
Give a very brief answer. 24.09. What is the ratio of the Emissions (1000 metric ton of CO2 equivalent) in 2000 in France to that in Greece?
Provide a short and direct response. 12.91. What is the ratio of the Emissions (1000 metric ton of CO2 equivalent) in 2005 in France to that in Greece?
Give a very brief answer. 12.59. What is the ratio of the Emissions (1000 metric ton of CO2 equivalent) in 2008 in France to that in Greece?
Keep it short and to the point. 14.27. What is the ratio of the Emissions (1000 metric ton of CO2 equivalent) of 1990 in France to that in Hungary?
Your answer should be compact. 8.41. What is the ratio of the Emissions (1000 metric ton of CO2 equivalent) in 2000 in France to that in Hungary?
Your answer should be very brief. 5.51. What is the ratio of the Emissions (1000 metric ton of CO2 equivalent) of 2005 in France to that in Hungary?
Provide a succinct answer. 3.81. What is the ratio of the Emissions (1000 metric ton of CO2 equivalent) in 2008 in France to that in Hungary?
Your response must be concise. 873.55. What is the ratio of the Emissions (1000 metric ton of CO2 equivalent) of 1990 in France to that in India?
Provide a short and direct response. 23.3. What is the ratio of the Emissions (1000 metric ton of CO2 equivalent) of 2000 in France to that in India?
Keep it short and to the point. 6.06. What is the ratio of the Emissions (1000 metric ton of CO2 equivalent) of 2005 in France to that in India?
Your response must be concise. 3.9. What is the ratio of the Emissions (1000 metric ton of CO2 equivalent) in 2008 in France to that in India?
Ensure brevity in your answer.  3.16. What is the ratio of the Emissions (1000 metric ton of CO2 equivalent) in 1990 in Georgia to that in Germany?
Ensure brevity in your answer.  0.04. What is the ratio of the Emissions (1000 metric ton of CO2 equivalent) in 2000 in Georgia to that in Germany?
Offer a terse response. 0.07. What is the ratio of the Emissions (1000 metric ton of CO2 equivalent) in 2005 in Georgia to that in Germany?
Offer a very short reply. 0.06. What is the ratio of the Emissions (1000 metric ton of CO2 equivalent) of 2008 in Georgia to that in Germany?
Give a very brief answer. 0.08. What is the ratio of the Emissions (1000 metric ton of CO2 equivalent) of 1990 in Georgia to that in Greece?
Your answer should be compact. 0.69. What is the ratio of the Emissions (1000 metric ton of CO2 equivalent) in 2000 in Georgia to that in Greece?
Make the answer very short. 0.82. What is the ratio of the Emissions (1000 metric ton of CO2 equivalent) of 2005 in Georgia to that in Greece?
Your answer should be very brief. 1.19. What is the ratio of the Emissions (1000 metric ton of CO2 equivalent) in 2008 in Georgia to that in Greece?
Offer a very short reply. 2.11. What is the ratio of the Emissions (1000 metric ton of CO2 equivalent) of 1990 in Georgia to that in Hungary?
Offer a very short reply. 0.24. What is the ratio of the Emissions (1000 metric ton of CO2 equivalent) in 2000 in Georgia to that in Hungary?
Your answer should be very brief. 0.35. What is the ratio of the Emissions (1000 metric ton of CO2 equivalent) of 2005 in Georgia to that in Hungary?
Provide a succinct answer. 0.36. What is the ratio of the Emissions (1000 metric ton of CO2 equivalent) in 2008 in Georgia to that in Hungary?
Ensure brevity in your answer.  129.42. What is the ratio of the Emissions (1000 metric ton of CO2 equivalent) of 1990 in Georgia to that in India?
Make the answer very short. 0.67. What is the ratio of the Emissions (1000 metric ton of CO2 equivalent) in 2000 in Georgia to that in India?
Give a very brief answer. 0.38. What is the ratio of the Emissions (1000 metric ton of CO2 equivalent) of 2005 in Georgia to that in India?
Make the answer very short. 0.37. What is the ratio of the Emissions (1000 metric ton of CO2 equivalent) in 2008 in Georgia to that in India?
Give a very brief answer. 0.47. What is the ratio of the Emissions (1000 metric ton of CO2 equivalent) in 1990 in Germany to that in Greece?
Your answer should be very brief. 18.48. What is the ratio of the Emissions (1000 metric ton of CO2 equivalent) in 2000 in Germany to that in Greece?
Ensure brevity in your answer.  12.47. What is the ratio of the Emissions (1000 metric ton of CO2 equivalent) in 2005 in Germany to that in Greece?
Your answer should be very brief. 19.07. What is the ratio of the Emissions (1000 metric ton of CO2 equivalent) in 2008 in Germany to that in Greece?
Your answer should be very brief. 26.45. What is the ratio of the Emissions (1000 metric ton of CO2 equivalent) of 1990 in Germany to that in Hungary?
Keep it short and to the point. 6.45. What is the ratio of the Emissions (1000 metric ton of CO2 equivalent) in 2000 in Germany to that in Hungary?
Give a very brief answer. 5.33. What is the ratio of the Emissions (1000 metric ton of CO2 equivalent) in 2005 in Germany to that in Hungary?
Offer a terse response. 5.78. What is the ratio of the Emissions (1000 metric ton of CO2 equivalent) of 2008 in Germany to that in Hungary?
Ensure brevity in your answer.  1619.73. What is the ratio of the Emissions (1000 metric ton of CO2 equivalent) in 1990 in Germany to that in India?
Make the answer very short. 17.88. What is the ratio of the Emissions (1000 metric ton of CO2 equivalent) in 2000 in Germany to that in India?
Make the answer very short. 5.85. What is the ratio of the Emissions (1000 metric ton of CO2 equivalent) of 2005 in Germany to that in India?
Ensure brevity in your answer.  5.91. What is the ratio of the Emissions (1000 metric ton of CO2 equivalent) of 2008 in Germany to that in India?
Ensure brevity in your answer.  5.86. What is the ratio of the Emissions (1000 metric ton of CO2 equivalent) in 1990 in Greece to that in Hungary?
Provide a succinct answer. 0.35. What is the ratio of the Emissions (1000 metric ton of CO2 equivalent) of 2000 in Greece to that in Hungary?
Make the answer very short. 0.43. What is the ratio of the Emissions (1000 metric ton of CO2 equivalent) of 2005 in Greece to that in Hungary?
Offer a terse response. 0.3. What is the ratio of the Emissions (1000 metric ton of CO2 equivalent) in 2008 in Greece to that in Hungary?
Ensure brevity in your answer.  61.23. What is the ratio of the Emissions (1000 metric ton of CO2 equivalent) of 1990 in Greece to that in India?
Your answer should be compact. 0.97. What is the ratio of the Emissions (1000 metric ton of CO2 equivalent) in 2000 in Greece to that in India?
Offer a terse response. 0.47. What is the ratio of the Emissions (1000 metric ton of CO2 equivalent) of 2005 in Greece to that in India?
Your answer should be very brief. 0.31. What is the ratio of the Emissions (1000 metric ton of CO2 equivalent) of 2008 in Greece to that in India?
Your answer should be compact. 0.22. What is the ratio of the Emissions (1000 metric ton of CO2 equivalent) of 1990 in Hungary to that in India?
Make the answer very short. 2.77. What is the ratio of the Emissions (1000 metric ton of CO2 equivalent) of 2000 in Hungary to that in India?
Offer a terse response. 1.1. What is the ratio of the Emissions (1000 metric ton of CO2 equivalent) of 2005 in Hungary to that in India?
Give a very brief answer. 1.02. What is the ratio of the Emissions (1000 metric ton of CO2 equivalent) in 2008 in Hungary to that in India?
Make the answer very short. 0. What is the difference between the highest and the second highest Emissions (1000 metric ton of CO2 equivalent) of 1990?
Provide a short and direct response. 6222.7. What is the difference between the highest and the second highest Emissions (1000 metric ton of CO2 equivalent) in 2000?
Make the answer very short. 335.9. What is the difference between the highest and the second highest Emissions (1000 metric ton of CO2 equivalent) in 2005?
Your answer should be compact. 3537.3. What is the difference between the highest and the second highest Emissions (1000 metric ton of CO2 equivalent) in 2008?
Make the answer very short. 4477.1. What is the difference between the highest and the lowest Emissions (1000 metric ton of CO2 equivalent) in 1990?
Provide a succinct answer. 2.60e+04. What is the difference between the highest and the lowest Emissions (1000 metric ton of CO2 equivalent) of 2000?
Offer a very short reply. 9323.3. What is the difference between the highest and the lowest Emissions (1000 metric ton of CO2 equivalent) of 2005?
Your answer should be very brief. 9863.1. What is the difference between the highest and the lowest Emissions (1000 metric ton of CO2 equivalent) of 2008?
Provide a short and direct response. 9712.4. 